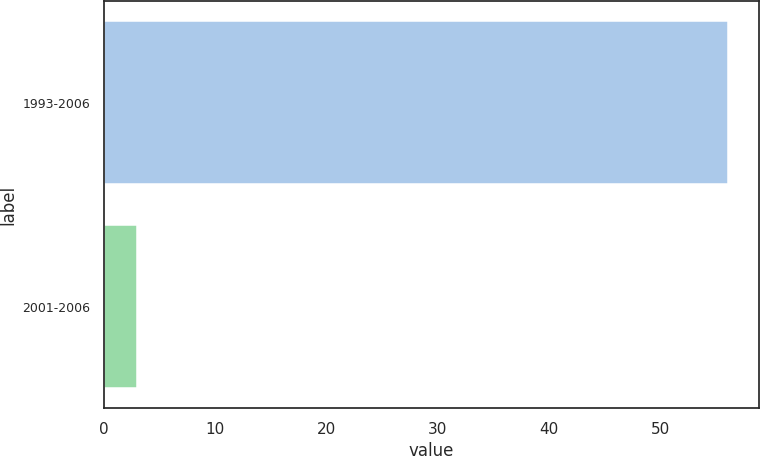<chart> <loc_0><loc_0><loc_500><loc_500><bar_chart><fcel>1993-2006<fcel>2001-2006<nl><fcel>56<fcel>3<nl></chart> 